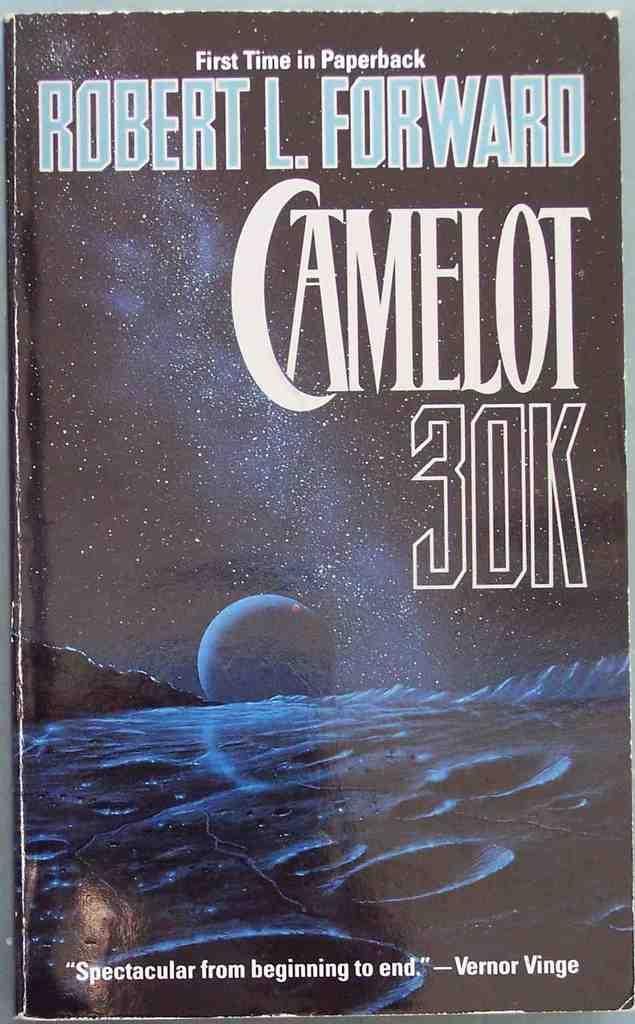What is the title?
Ensure brevity in your answer.  Camelot 30k. 